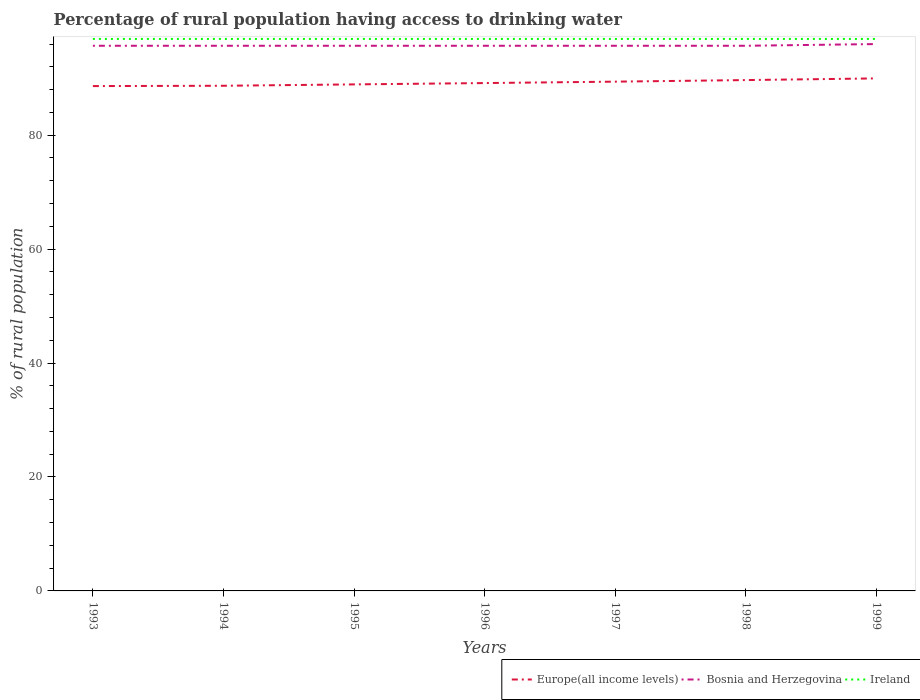Does the line corresponding to Europe(all income levels) intersect with the line corresponding to Bosnia and Herzegovina?
Give a very brief answer. No. Is the number of lines equal to the number of legend labels?
Keep it short and to the point. Yes. Across all years, what is the maximum percentage of rural population having access to drinking water in Europe(all income levels)?
Offer a terse response. 88.62. What is the difference between the highest and the second highest percentage of rural population having access to drinking water in Bosnia and Herzegovina?
Keep it short and to the point. 0.3. Is the percentage of rural population having access to drinking water in Europe(all income levels) strictly greater than the percentage of rural population having access to drinking water in Ireland over the years?
Provide a short and direct response. Yes. How many years are there in the graph?
Make the answer very short. 7. How are the legend labels stacked?
Provide a succinct answer. Horizontal. What is the title of the graph?
Keep it short and to the point. Percentage of rural population having access to drinking water. Does "Ethiopia" appear as one of the legend labels in the graph?
Give a very brief answer. No. What is the label or title of the Y-axis?
Give a very brief answer. % of rural population. What is the % of rural population in Europe(all income levels) in 1993?
Offer a terse response. 88.62. What is the % of rural population in Bosnia and Herzegovina in 1993?
Keep it short and to the point. 95.7. What is the % of rural population of Ireland in 1993?
Give a very brief answer. 96.9. What is the % of rural population in Europe(all income levels) in 1994?
Ensure brevity in your answer.  88.68. What is the % of rural population in Bosnia and Herzegovina in 1994?
Ensure brevity in your answer.  95.7. What is the % of rural population in Ireland in 1994?
Give a very brief answer. 96.9. What is the % of rural population of Europe(all income levels) in 1995?
Provide a succinct answer. 88.92. What is the % of rural population of Bosnia and Herzegovina in 1995?
Your answer should be compact. 95.7. What is the % of rural population in Ireland in 1995?
Provide a succinct answer. 96.9. What is the % of rural population of Europe(all income levels) in 1996?
Provide a succinct answer. 89.15. What is the % of rural population in Bosnia and Herzegovina in 1996?
Provide a short and direct response. 95.7. What is the % of rural population of Ireland in 1996?
Make the answer very short. 96.9. What is the % of rural population in Europe(all income levels) in 1997?
Keep it short and to the point. 89.4. What is the % of rural population of Bosnia and Herzegovina in 1997?
Provide a short and direct response. 95.7. What is the % of rural population in Ireland in 1997?
Provide a short and direct response. 96.9. What is the % of rural population in Europe(all income levels) in 1998?
Make the answer very short. 89.68. What is the % of rural population in Bosnia and Herzegovina in 1998?
Offer a very short reply. 95.7. What is the % of rural population in Ireland in 1998?
Your answer should be compact. 96.9. What is the % of rural population of Europe(all income levels) in 1999?
Offer a terse response. 89.97. What is the % of rural population of Bosnia and Herzegovina in 1999?
Your response must be concise. 96. What is the % of rural population in Ireland in 1999?
Your answer should be compact. 96.9. Across all years, what is the maximum % of rural population of Europe(all income levels)?
Make the answer very short. 89.97. Across all years, what is the maximum % of rural population in Bosnia and Herzegovina?
Offer a terse response. 96. Across all years, what is the maximum % of rural population in Ireland?
Offer a very short reply. 96.9. Across all years, what is the minimum % of rural population in Europe(all income levels)?
Offer a terse response. 88.62. Across all years, what is the minimum % of rural population of Bosnia and Herzegovina?
Offer a terse response. 95.7. Across all years, what is the minimum % of rural population of Ireland?
Provide a succinct answer. 96.9. What is the total % of rural population of Europe(all income levels) in the graph?
Your response must be concise. 624.43. What is the total % of rural population of Bosnia and Herzegovina in the graph?
Offer a terse response. 670.2. What is the total % of rural population of Ireland in the graph?
Your answer should be very brief. 678.3. What is the difference between the % of rural population of Europe(all income levels) in 1993 and that in 1994?
Your response must be concise. -0.05. What is the difference between the % of rural population in Ireland in 1993 and that in 1994?
Your response must be concise. 0. What is the difference between the % of rural population of Europe(all income levels) in 1993 and that in 1995?
Your answer should be compact. -0.29. What is the difference between the % of rural population of Europe(all income levels) in 1993 and that in 1996?
Provide a succinct answer. -0.53. What is the difference between the % of rural population in Bosnia and Herzegovina in 1993 and that in 1996?
Offer a very short reply. 0. What is the difference between the % of rural population in Ireland in 1993 and that in 1996?
Ensure brevity in your answer.  0. What is the difference between the % of rural population in Europe(all income levels) in 1993 and that in 1997?
Your answer should be very brief. -0.78. What is the difference between the % of rural population of Europe(all income levels) in 1993 and that in 1998?
Provide a succinct answer. -1.05. What is the difference between the % of rural population in Bosnia and Herzegovina in 1993 and that in 1998?
Ensure brevity in your answer.  0. What is the difference between the % of rural population in Europe(all income levels) in 1993 and that in 1999?
Make the answer very short. -1.35. What is the difference between the % of rural population in Europe(all income levels) in 1994 and that in 1995?
Your answer should be compact. -0.24. What is the difference between the % of rural population of Bosnia and Herzegovina in 1994 and that in 1995?
Your response must be concise. 0. What is the difference between the % of rural population in Ireland in 1994 and that in 1995?
Ensure brevity in your answer.  0. What is the difference between the % of rural population in Europe(all income levels) in 1994 and that in 1996?
Make the answer very short. -0.47. What is the difference between the % of rural population in Ireland in 1994 and that in 1996?
Provide a short and direct response. 0. What is the difference between the % of rural population of Europe(all income levels) in 1994 and that in 1997?
Offer a terse response. -0.72. What is the difference between the % of rural population of Ireland in 1994 and that in 1997?
Make the answer very short. 0. What is the difference between the % of rural population in Europe(all income levels) in 1994 and that in 1998?
Your answer should be compact. -1. What is the difference between the % of rural population in Ireland in 1994 and that in 1998?
Provide a short and direct response. 0. What is the difference between the % of rural population in Europe(all income levels) in 1994 and that in 1999?
Your answer should be very brief. -1.29. What is the difference between the % of rural population in Bosnia and Herzegovina in 1994 and that in 1999?
Your answer should be compact. -0.3. What is the difference between the % of rural population in Europe(all income levels) in 1995 and that in 1996?
Offer a very short reply. -0.23. What is the difference between the % of rural population of Bosnia and Herzegovina in 1995 and that in 1996?
Offer a very short reply. 0. What is the difference between the % of rural population in Ireland in 1995 and that in 1996?
Your answer should be very brief. 0. What is the difference between the % of rural population of Europe(all income levels) in 1995 and that in 1997?
Keep it short and to the point. -0.48. What is the difference between the % of rural population in Bosnia and Herzegovina in 1995 and that in 1997?
Your answer should be compact. 0. What is the difference between the % of rural population in Europe(all income levels) in 1995 and that in 1998?
Your answer should be very brief. -0.76. What is the difference between the % of rural population of Ireland in 1995 and that in 1998?
Offer a very short reply. 0. What is the difference between the % of rural population in Europe(all income levels) in 1995 and that in 1999?
Make the answer very short. -1.05. What is the difference between the % of rural population of Ireland in 1995 and that in 1999?
Your answer should be compact. 0. What is the difference between the % of rural population of Europe(all income levels) in 1996 and that in 1997?
Ensure brevity in your answer.  -0.25. What is the difference between the % of rural population of Bosnia and Herzegovina in 1996 and that in 1997?
Your response must be concise. 0. What is the difference between the % of rural population in Europe(all income levels) in 1996 and that in 1998?
Keep it short and to the point. -0.52. What is the difference between the % of rural population in Ireland in 1996 and that in 1998?
Give a very brief answer. 0. What is the difference between the % of rural population in Europe(all income levels) in 1996 and that in 1999?
Offer a terse response. -0.82. What is the difference between the % of rural population of Bosnia and Herzegovina in 1996 and that in 1999?
Your answer should be very brief. -0.3. What is the difference between the % of rural population in Europe(all income levels) in 1997 and that in 1998?
Keep it short and to the point. -0.28. What is the difference between the % of rural population of Bosnia and Herzegovina in 1997 and that in 1998?
Offer a terse response. 0. What is the difference between the % of rural population in Ireland in 1997 and that in 1998?
Offer a very short reply. 0. What is the difference between the % of rural population of Europe(all income levels) in 1997 and that in 1999?
Ensure brevity in your answer.  -0.57. What is the difference between the % of rural population of Ireland in 1997 and that in 1999?
Your answer should be very brief. 0. What is the difference between the % of rural population of Europe(all income levels) in 1998 and that in 1999?
Offer a terse response. -0.3. What is the difference between the % of rural population in Bosnia and Herzegovina in 1998 and that in 1999?
Offer a terse response. -0.3. What is the difference between the % of rural population of Ireland in 1998 and that in 1999?
Provide a succinct answer. 0. What is the difference between the % of rural population in Europe(all income levels) in 1993 and the % of rural population in Bosnia and Herzegovina in 1994?
Ensure brevity in your answer.  -7.08. What is the difference between the % of rural population of Europe(all income levels) in 1993 and the % of rural population of Ireland in 1994?
Your answer should be very brief. -8.28. What is the difference between the % of rural population of Bosnia and Herzegovina in 1993 and the % of rural population of Ireland in 1994?
Your answer should be compact. -1.2. What is the difference between the % of rural population of Europe(all income levels) in 1993 and the % of rural population of Bosnia and Herzegovina in 1995?
Your response must be concise. -7.08. What is the difference between the % of rural population of Europe(all income levels) in 1993 and the % of rural population of Ireland in 1995?
Your response must be concise. -8.28. What is the difference between the % of rural population in Bosnia and Herzegovina in 1993 and the % of rural population in Ireland in 1995?
Your answer should be compact. -1.2. What is the difference between the % of rural population of Europe(all income levels) in 1993 and the % of rural population of Bosnia and Herzegovina in 1996?
Offer a very short reply. -7.08. What is the difference between the % of rural population in Europe(all income levels) in 1993 and the % of rural population in Ireland in 1996?
Your answer should be compact. -8.28. What is the difference between the % of rural population of Europe(all income levels) in 1993 and the % of rural population of Bosnia and Herzegovina in 1997?
Offer a terse response. -7.08. What is the difference between the % of rural population of Europe(all income levels) in 1993 and the % of rural population of Ireland in 1997?
Make the answer very short. -8.28. What is the difference between the % of rural population of Europe(all income levels) in 1993 and the % of rural population of Bosnia and Herzegovina in 1998?
Ensure brevity in your answer.  -7.08. What is the difference between the % of rural population in Europe(all income levels) in 1993 and the % of rural population in Ireland in 1998?
Offer a terse response. -8.28. What is the difference between the % of rural population in Bosnia and Herzegovina in 1993 and the % of rural population in Ireland in 1998?
Ensure brevity in your answer.  -1.2. What is the difference between the % of rural population in Europe(all income levels) in 1993 and the % of rural population in Bosnia and Herzegovina in 1999?
Provide a succinct answer. -7.38. What is the difference between the % of rural population of Europe(all income levels) in 1993 and the % of rural population of Ireland in 1999?
Provide a short and direct response. -8.28. What is the difference between the % of rural population in Europe(all income levels) in 1994 and the % of rural population in Bosnia and Herzegovina in 1995?
Offer a terse response. -7.02. What is the difference between the % of rural population in Europe(all income levels) in 1994 and the % of rural population in Ireland in 1995?
Make the answer very short. -8.22. What is the difference between the % of rural population of Europe(all income levels) in 1994 and the % of rural population of Bosnia and Herzegovina in 1996?
Offer a terse response. -7.02. What is the difference between the % of rural population in Europe(all income levels) in 1994 and the % of rural population in Ireland in 1996?
Give a very brief answer. -8.22. What is the difference between the % of rural population in Europe(all income levels) in 1994 and the % of rural population in Bosnia and Herzegovina in 1997?
Provide a succinct answer. -7.02. What is the difference between the % of rural population in Europe(all income levels) in 1994 and the % of rural population in Ireland in 1997?
Your answer should be very brief. -8.22. What is the difference between the % of rural population in Bosnia and Herzegovina in 1994 and the % of rural population in Ireland in 1997?
Keep it short and to the point. -1.2. What is the difference between the % of rural population in Europe(all income levels) in 1994 and the % of rural population in Bosnia and Herzegovina in 1998?
Ensure brevity in your answer.  -7.02. What is the difference between the % of rural population of Europe(all income levels) in 1994 and the % of rural population of Ireland in 1998?
Keep it short and to the point. -8.22. What is the difference between the % of rural population in Bosnia and Herzegovina in 1994 and the % of rural population in Ireland in 1998?
Ensure brevity in your answer.  -1.2. What is the difference between the % of rural population of Europe(all income levels) in 1994 and the % of rural population of Bosnia and Herzegovina in 1999?
Provide a short and direct response. -7.32. What is the difference between the % of rural population in Europe(all income levels) in 1994 and the % of rural population in Ireland in 1999?
Your response must be concise. -8.22. What is the difference between the % of rural population in Europe(all income levels) in 1995 and the % of rural population in Bosnia and Herzegovina in 1996?
Provide a succinct answer. -6.78. What is the difference between the % of rural population of Europe(all income levels) in 1995 and the % of rural population of Ireland in 1996?
Your answer should be very brief. -7.98. What is the difference between the % of rural population of Bosnia and Herzegovina in 1995 and the % of rural population of Ireland in 1996?
Provide a succinct answer. -1.2. What is the difference between the % of rural population in Europe(all income levels) in 1995 and the % of rural population in Bosnia and Herzegovina in 1997?
Offer a terse response. -6.78. What is the difference between the % of rural population in Europe(all income levels) in 1995 and the % of rural population in Ireland in 1997?
Your response must be concise. -7.98. What is the difference between the % of rural population of Europe(all income levels) in 1995 and the % of rural population of Bosnia and Herzegovina in 1998?
Keep it short and to the point. -6.78. What is the difference between the % of rural population in Europe(all income levels) in 1995 and the % of rural population in Ireland in 1998?
Keep it short and to the point. -7.98. What is the difference between the % of rural population in Europe(all income levels) in 1995 and the % of rural population in Bosnia and Herzegovina in 1999?
Your answer should be compact. -7.08. What is the difference between the % of rural population of Europe(all income levels) in 1995 and the % of rural population of Ireland in 1999?
Provide a succinct answer. -7.98. What is the difference between the % of rural population in Europe(all income levels) in 1996 and the % of rural population in Bosnia and Herzegovina in 1997?
Offer a terse response. -6.55. What is the difference between the % of rural population of Europe(all income levels) in 1996 and the % of rural population of Ireland in 1997?
Your response must be concise. -7.75. What is the difference between the % of rural population in Bosnia and Herzegovina in 1996 and the % of rural population in Ireland in 1997?
Offer a very short reply. -1.2. What is the difference between the % of rural population of Europe(all income levels) in 1996 and the % of rural population of Bosnia and Herzegovina in 1998?
Your answer should be very brief. -6.55. What is the difference between the % of rural population in Europe(all income levels) in 1996 and the % of rural population in Ireland in 1998?
Offer a very short reply. -7.75. What is the difference between the % of rural population of Bosnia and Herzegovina in 1996 and the % of rural population of Ireland in 1998?
Offer a terse response. -1.2. What is the difference between the % of rural population in Europe(all income levels) in 1996 and the % of rural population in Bosnia and Herzegovina in 1999?
Make the answer very short. -6.85. What is the difference between the % of rural population in Europe(all income levels) in 1996 and the % of rural population in Ireland in 1999?
Make the answer very short. -7.75. What is the difference between the % of rural population of Bosnia and Herzegovina in 1996 and the % of rural population of Ireland in 1999?
Offer a terse response. -1.2. What is the difference between the % of rural population in Europe(all income levels) in 1997 and the % of rural population in Bosnia and Herzegovina in 1998?
Provide a short and direct response. -6.3. What is the difference between the % of rural population in Europe(all income levels) in 1997 and the % of rural population in Ireland in 1998?
Offer a terse response. -7.5. What is the difference between the % of rural population in Bosnia and Herzegovina in 1997 and the % of rural population in Ireland in 1998?
Your answer should be very brief. -1.2. What is the difference between the % of rural population of Europe(all income levels) in 1997 and the % of rural population of Bosnia and Herzegovina in 1999?
Offer a very short reply. -6.6. What is the difference between the % of rural population in Europe(all income levels) in 1997 and the % of rural population in Ireland in 1999?
Give a very brief answer. -7.5. What is the difference between the % of rural population in Bosnia and Herzegovina in 1997 and the % of rural population in Ireland in 1999?
Offer a terse response. -1.2. What is the difference between the % of rural population of Europe(all income levels) in 1998 and the % of rural population of Bosnia and Herzegovina in 1999?
Keep it short and to the point. -6.32. What is the difference between the % of rural population of Europe(all income levels) in 1998 and the % of rural population of Ireland in 1999?
Offer a terse response. -7.22. What is the difference between the % of rural population in Bosnia and Herzegovina in 1998 and the % of rural population in Ireland in 1999?
Keep it short and to the point. -1.2. What is the average % of rural population in Europe(all income levels) per year?
Make the answer very short. 89.2. What is the average % of rural population of Bosnia and Herzegovina per year?
Provide a succinct answer. 95.74. What is the average % of rural population in Ireland per year?
Give a very brief answer. 96.9. In the year 1993, what is the difference between the % of rural population in Europe(all income levels) and % of rural population in Bosnia and Herzegovina?
Your answer should be very brief. -7.08. In the year 1993, what is the difference between the % of rural population of Europe(all income levels) and % of rural population of Ireland?
Give a very brief answer. -8.28. In the year 1993, what is the difference between the % of rural population of Bosnia and Herzegovina and % of rural population of Ireland?
Provide a short and direct response. -1.2. In the year 1994, what is the difference between the % of rural population of Europe(all income levels) and % of rural population of Bosnia and Herzegovina?
Provide a short and direct response. -7.02. In the year 1994, what is the difference between the % of rural population of Europe(all income levels) and % of rural population of Ireland?
Offer a terse response. -8.22. In the year 1995, what is the difference between the % of rural population of Europe(all income levels) and % of rural population of Bosnia and Herzegovina?
Keep it short and to the point. -6.78. In the year 1995, what is the difference between the % of rural population in Europe(all income levels) and % of rural population in Ireland?
Keep it short and to the point. -7.98. In the year 1995, what is the difference between the % of rural population in Bosnia and Herzegovina and % of rural population in Ireland?
Give a very brief answer. -1.2. In the year 1996, what is the difference between the % of rural population in Europe(all income levels) and % of rural population in Bosnia and Herzegovina?
Offer a terse response. -6.55. In the year 1996, what is the difference between the % of rural population of Europe(all income levels) and % of rural population of Ireland?
Provide a succinct answer. -7.75. In the year 1997, what is the difference between the % of rural population in Europe(all income levels) and % of rural population in Bosnia and Herzegovina?
Your response must be concise. -6.3. In the year 1997, what is the difference between the % of rural population in Europe(all income levels) and % of rural population in Ireland?
Your response must be concise. -7.5. In the year 1998, what is the difference between the % of rural population of Europe(all income levels) and % of rural population of Bosnia and Herzegovina?
Provide a succinct answer. -6.02. In the year 1998, what is the difference between the % of rural population of Europe(all income levels) and % of rural population of Ireland?
Ensure brevity in your answer.  -7.22. In the year 1998, what is the difference between the % of rural population of Bosnia and Herzegovina and % of rural population of Ireland?
Provide a succinct answer. -1.2. In the year 1999, what is the difference between the % of rural population of Europe(all income levels) and % of rural population of Bosnia and Herzegovina?
Your answer should be very brief. -6.03. In the year 1999, what is the difference between the % of rural population of Europe(all income levels) and % of rural population of Ireland?
Make the answer very short. -6.93. What is the ratio of the % of rural population in Europe(all income levels) in 1993 to that in 1994?
Offer a terse response. 1. What is the ratio of the % of rural population of Bosnia and Herzegovina in 1993 to that in 1994?
Your answer should be very brief. 1. What is the ratio of the % of rural population in Ireland in 1993 to that in 1994?
Provide a short and direct response. 1. What is the ratio of the % of rural population in Europe(all income levels) in 1993 to that in 1995?
Provide a short and direct response. 1. What is the ratio of the % of rural population in Europe(all income levels) in 1993 to that in 1996?
Offer a terse response. 0.99. What is the ratio of the % of rural population of Bosnia and Herzegovina in 1993 to that in 1997?
Make the answer very short. 1. What is the ratio of the % of rural population in Europe(all income levels) in 1993 to that in 1998?
Your answer should be very brief. 0.99. What is the ratio of the % of rural population of Bosnia and Herzegovina in 1993 to that in 1998?
Your answer should be compact. 1. What is the ratio of the % of rural population in Ireland in 1993 to that in 1998?
Ensure brevity in your answer.  1. What is the ratio of the % of rural population of Europe(all income levels) in 1993 to that in 1999?
Ensure brevity in your answer.  0.98. What is the ratio of the % of rural population in Bosnia and Herzegovina in 1993 to that in 1999?
Offer a very short reply. 1. What is the ratio of the % of rural population in Bosnia and Herzegovina in 1994 to that in 1995?
Provide a succinct answer. 1. What is the ratio of the % of rural population of Ireland in 1994 to that in 1995?
Provide a succinct answer. 1. What is the ratio of the % of rural population in Bosnia and Herzegovina in 1994 to that in 1996?
Your answer should be compact. 1. What is the ratio of the % of rural population of Europe(all income levels) in 1994 to that in 1997?
Ensure brevity in your answer.  0.99. What is the ratio of the % of rural population in Bosnia and Herzegovina in 1994 to that in 1997?
Offer a terse response. 1. What is the ratio of the % of rural population in Ireland in 1994 to that in 1997?
Your response must be concise. 1. What is the ratio of the % of rural population in Europe(all income levels) in 1994 to that in 1998?
Ensure brevity in your answer.  0.99. What is the ratio of the % of rural population of Bosnia and Herzegovina in 1994 to that in 1998?
Your response must be concise. 1. What is the ratio of the % of rural population of Ireland in 1994 to that in 1998?
Your answer should be compact. 1. What is the ratio of the % of rural population in Europe(all income levels) in 1994 to that in 1999?
Offer a very short reply. 0.99. What is the ratio of the % of rural population of Ireland in 1994 to that in 1999?
Offer a terse response. 1. What is the ratio of the % of rural population of Europe(all income levels) in 1995 to that in 1996?
Make the answer very short. 1. What is the ratio of the % of rural population in Ireland in 1995 to that in 1996?
Keep it short and to the point. 1. What is the ratio of the % of rural population of Europe(all income levels) in 1995 to that in 1997?
Ensure brevity in your answer.  0.99. What is the ratio of the % of rural population of Europe(all income levels) in 1995 to that in 1998?
Ensure brevity in your answer.  0.99. What is the ratio of the % of rural population of Bosnia and Herzegovina in 1995 to that in 1998?
Make the answer very short. 1. What is the ratio of the % of rural population in Europe(all income levels) in 1995 to that in 1999?
Your response must be concise. 0.99. What is the ratio of the % of rural population in Ireland in 1995 to that in 1999?
Your response must be concise. 1. What is the ratio of the % of rural population of Europe(all income levels) in 1996 to that in 1997?
Your response must be concise. 1. What is the ratio of the % of rural population in Europe(all income levels) in 1996 to that in 1998?
Offer a very short reply. 0.99. What is the ratio of the % of rural population in Europe(all income levels) in 1996 to that in 1999?
Offer a very short reply. 0.99. What is the ratio of the % of rural population in Europe(all income levels) in 1997 to that in 1998?
Your answer should be compact. 1. What is the ratio of the % of rural population in Ireland in 1997 to that in 1998?
Your response must be concise. 1. What is the ratio of the % of rural population of Bosnia and Herzegovina in 1998 to that in 1999?
Ensure brevity in your answer.  1. What is the ratio of the % of rural population in Ireland in 1998 to that in 1999?
Your response must be concise. 1. What is the difference between the highest and the second highest % of rural population in Europe(all income levels)?
Your answer should be compact. 0.3. What is the difference between the highest and the second highest % of rural population of Bosnia and Herzegovina?
Keep it short and to the point. 0.3. What is the difference between the highest and the second highest % of rural population in Ireland?
Your answer should be compact. 0. What is the difference between the highest and the lowest % of rural population in Europe(all income levels)?
Provide a succinct answer. 1.35. What is the difference between the highest and the lowest % of rural population in Bosnia and Herzegovina?
Provide a short and direct response. 0.3. 